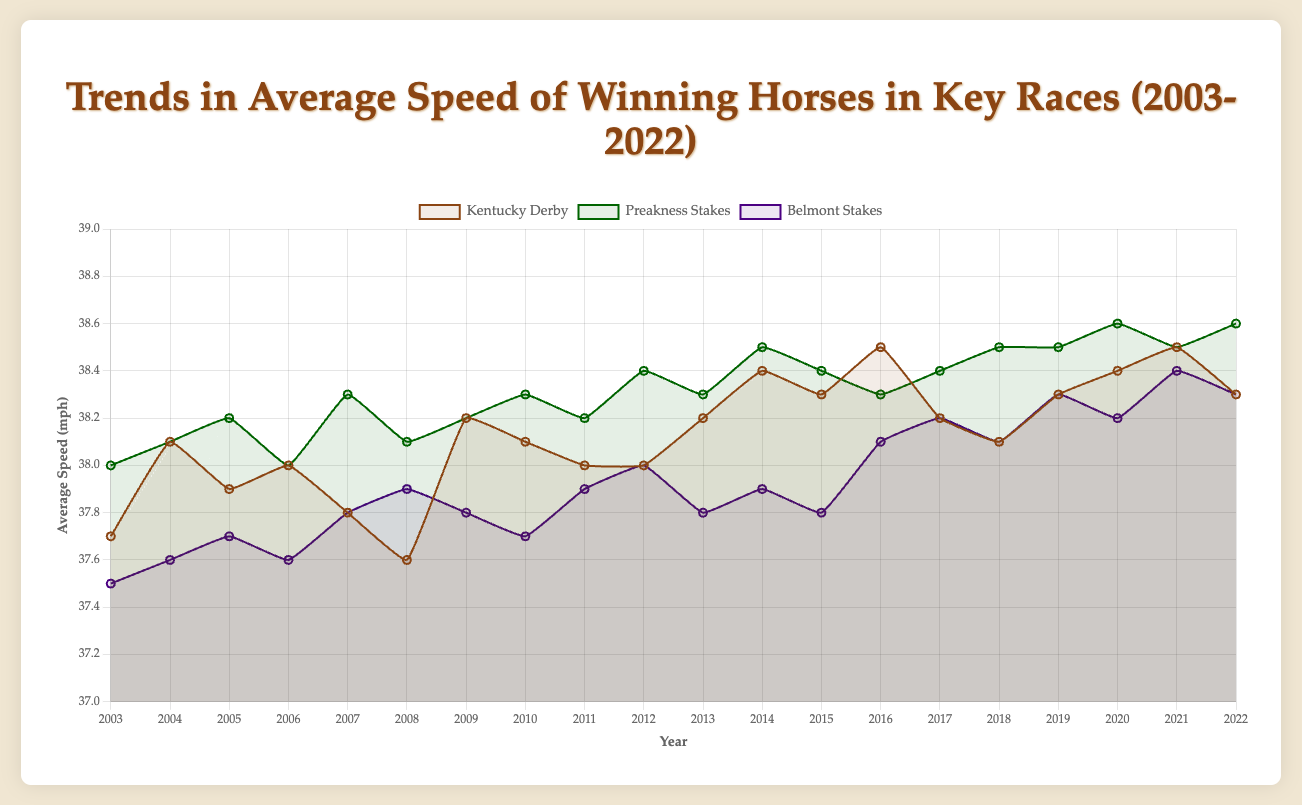What's the overall trend in the average speed of winning horses in the Kentucky Derby from 2003 to 2022? From the figure, we can observe that the overall trend in the average speed of winning horses in the Kentucky Derby shows a slight increase. The average speed starts around 37.7 mph in 2003 and ends around 38.3 mph in 2022, with some fluctuations.
Answer: The trend is slightly increasing In which race did the average speed of winning horses increase the most from 2003 to 2022? By observing the line plot, we need to compare the beginning and ending points of each race's speed line. The Belmont Stakes race shows the most significant increase, from 37.5 mph in 2003 to about 38.3 mph in 2022, marking an increase of 0.8 mph.
Answer: Belmont Stakes What year did the Belmont Stakes race first exceed an average speed of 38 mph? Look at the plot line for the Belmont Stakes and identify the first data point above 38 mph. This happened in 2012 when the average speed was 38 mph.
Answer: 2012 Which key race had the highest average speed of winning horses in 2022? Compare the plotted points for each race in 2022. The Preakness Stakes has the highest average speed, around 38.6 mph.
Answer: Preakness Stakes Between 2010 and 2015, which race showed the most consistent average speeds of winning horses? We need to check for minimal fluctuation in the plotted lines within this period. The Preakness Stakes shows a stable line with speeds mostly between 38.2 mph and 38.5 mph with very little variation.
Answer: Preakness Stakes In what year did the Kentucky Derby have the highest increase in average speed compared to the previous year? To find this, we need to compare the year-over-year changes in the Kentucky Derby line. The highest increase occurs from 2015 to 2016, where the speed increased from 38.3 mph to 38.5 mph, a 0.2 mph increase.
Answer: 2016 Which race consistently had the highest average speeds of winning horses over the 20 years? Looking at the overall trends and heights of the plotted lines, Preakness Stakes maintained the highest average speeds, especially evident since its line is generally higher than the others.
Answer: Preakness Stakes What were the average speeds of winning horses for the Kentucky Derby and Preakness Stakes in 2010, and which one was higher? According to the plot, the Kentucky Derby had an average speed of around 38.1 mph while the Preakness Stakes was approximately 38.3 mph in 2010. Thus, Preakness Stakes had the higher speed.
Answer: Preakness Stakes How does the average speed of the winning horse trend in the Belmont Stakes race over the last five years (2018-2022)? Observe the Belmont Stakes line from 2018 to 2022. The speeds first increase slightly, peak at 38.4 mph in 2021, and then slightly decrease to 38.3 mph in 2022.
Answer: Slightly increasing then stabilizing 